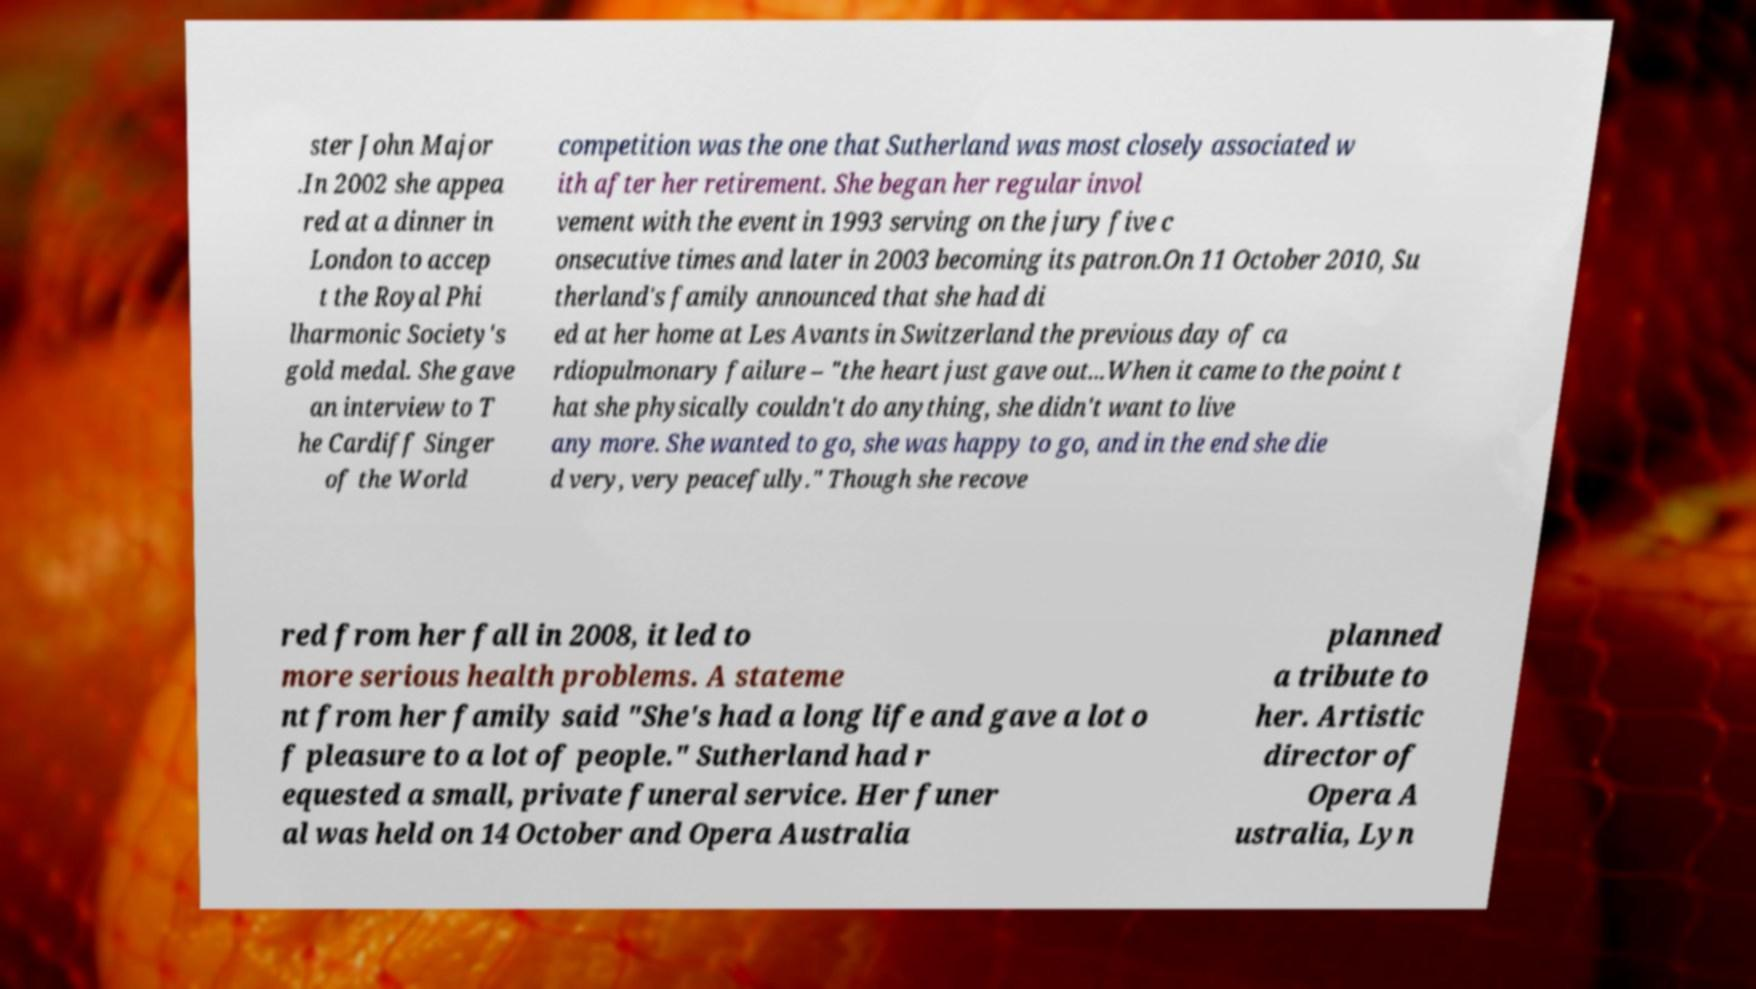Could you assist in decoding the text presented in this image and type it out clearly? ster John Major .In 2002 she appea red at a dinner in London to accep t the Royal Phi lharmonic Society's gold medal. She gave an interview to T he Cardiff Singer of the World competition was the one that Sutherland was most closely associated w ith after her retirement. She began her regular invol vement with the event in 1993 serving on the jury five c onsecutive times and later in 2003 becoming its patron.On 11 October 2010, Su therland's family announced that she had di ed at her home at Les Avants in Switzerland the previous day of ca rdiopulmonary failure – "the heart just gave out...When it came to the point t hat she physically couldn't do anything, she didn't want to live any more. She wanted to go, she was happy to go, and in the end she die d very, very peacefully." Though she recove red from her fall in 2008, it led to more serious health problems. A stateme nt from her family said "She's had a long life and gave a lot o f pleasure to a lot of people." Sutherland had r equested a small, private funeral service. Her funer al was held on 14 October and Opera Australia planned a tribute to her. Artistic director of Opera A ustralia, Lyn 